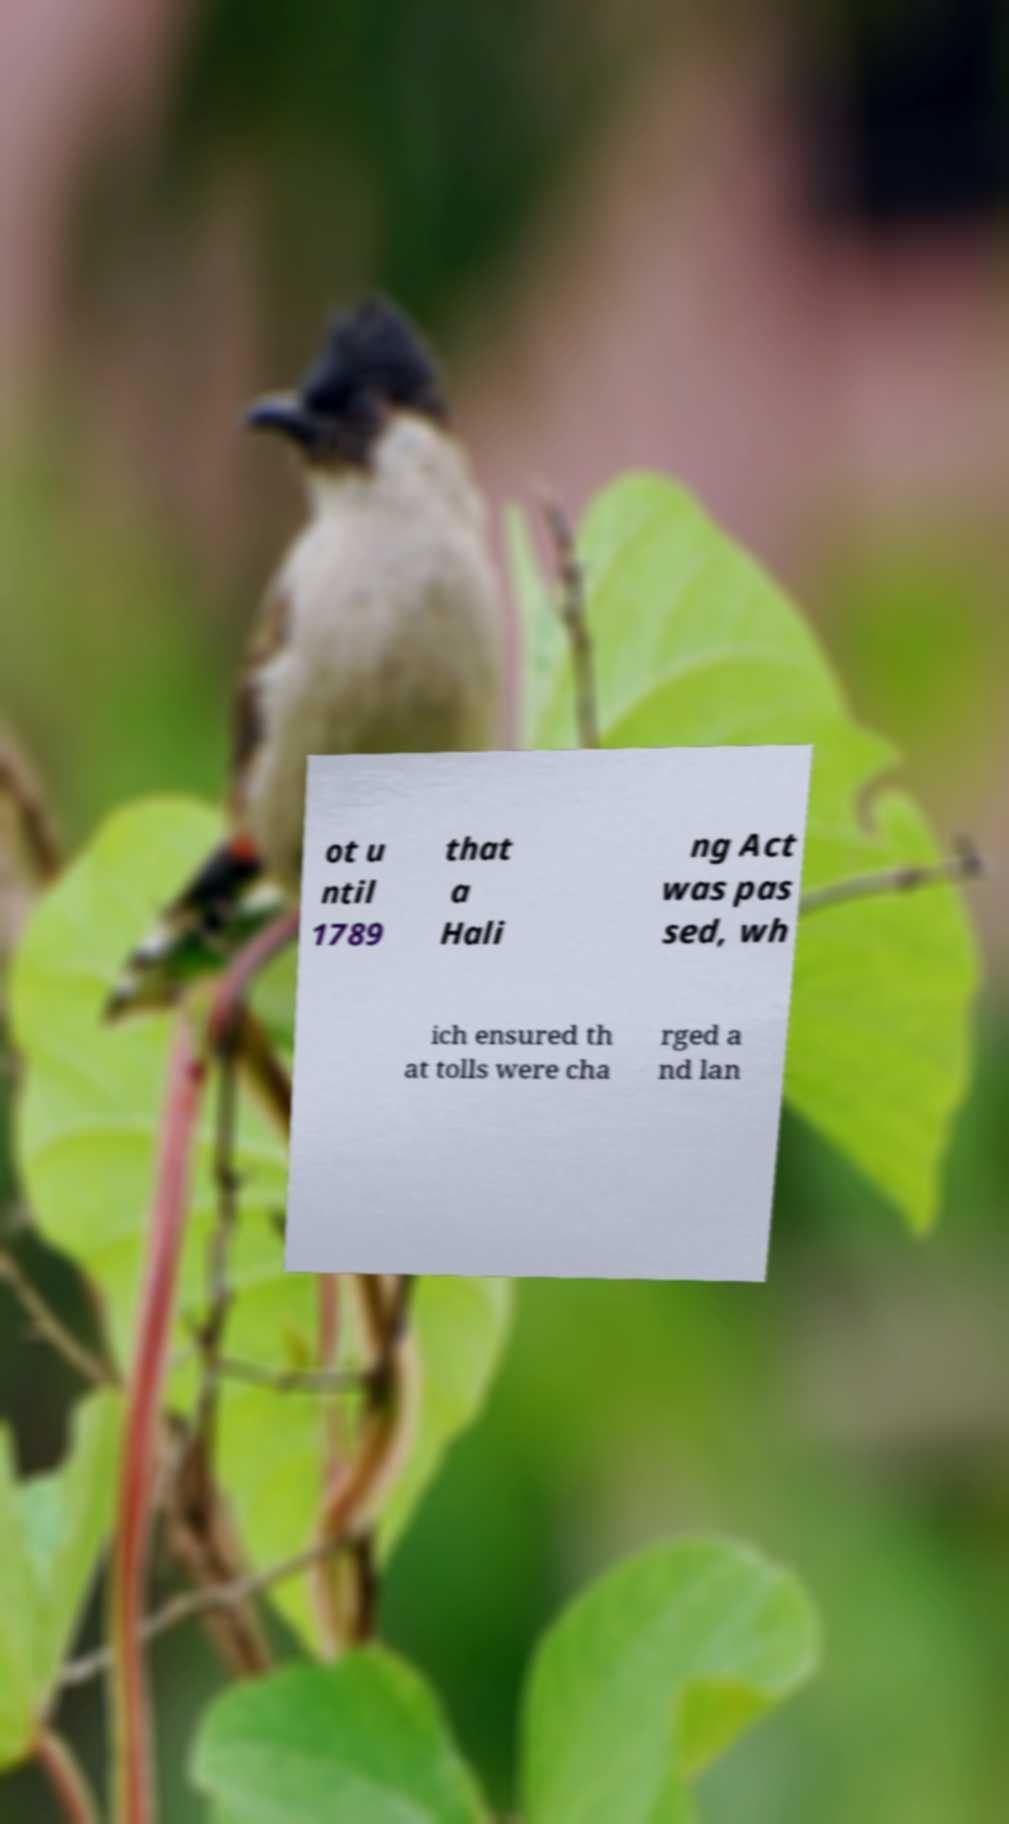Please identify and transcribe the text found in this image. ot u ntil 1789 that a Hali ng Act was pas sed, wh ich ensured th at tolls were cha rged a nd lan 